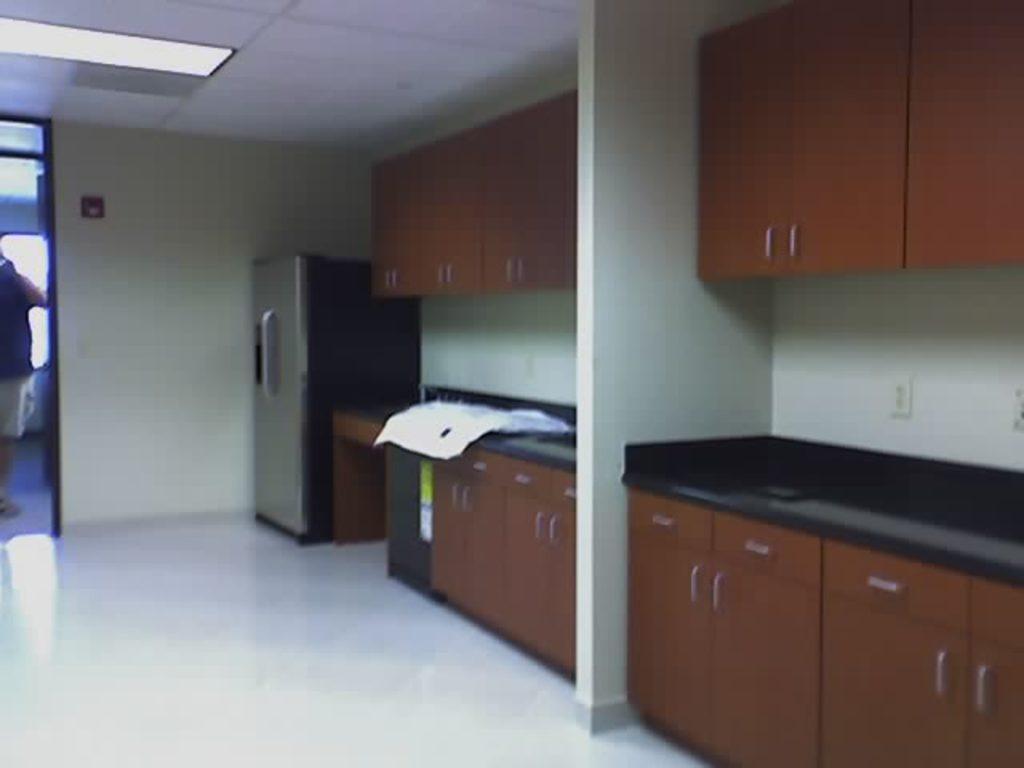Please provide a concise description of this image. In this image we can see cupboards, refrigerator, light, and ceiling. On the left side of the image we can see a person standing on the floor. 